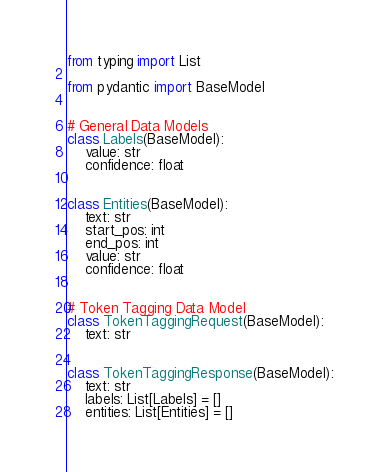<code> <loc_0><loc_0><loc_500><loc_500><_Python_>from typing import List

from pydantic import BaseModel


# General Data Models
class Labels(BaseModel):
    value: str
    confidence: float


class Entities(BaseModel):
    text: str
    start_pos: int
    end_pos: int
    value: str
    confidence: float


# Token Tagging Data Model
class TokenTaggingRequest(BaseModel):
    text: str


class TokenTaggingResponse(BaseModel):
    text: str
    labels: List[Labels] = []
    entities: List[Entities] = []
</code> 